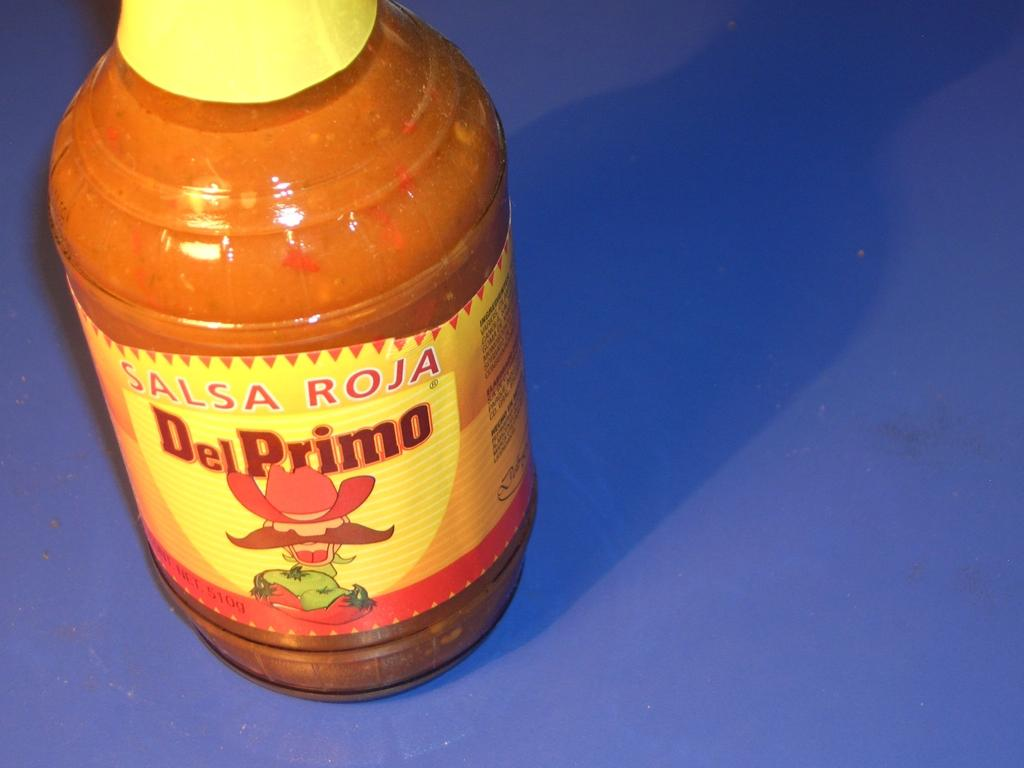<image>
Render a clear and concise summary of the photo. A bottle of Del Primo salsa is present against a blue background. 